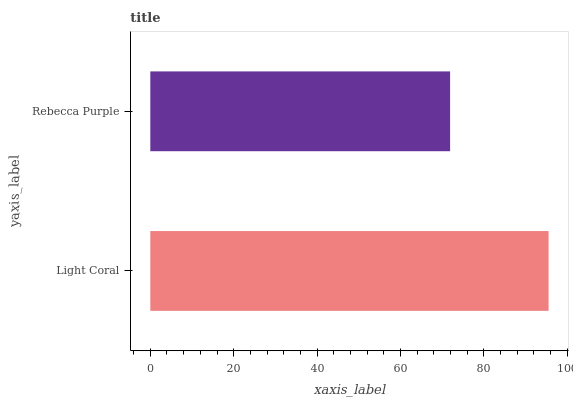Is Rebecca Purple the minimum?
Answer yes or no. Yes. Is Light Coral the maximum?
Answer yes or no. Yes. Is Rebecca Purple the maximum?
Answer yes or no. No. Is Light Coral greater than Rebecca Purple?
Answer yes or no. Yes. Is Rebecca Purple less than Light Coral?
Answer yes or no. Yes. Is Rebecca Purple greater than Light Coral?
Answer yes or no. No. Is Light Coral less than Rebecca Purple?
Answer yes or no. No. Is Light Coral the high median?
Answer yes or no. Yes. Is Rebecca Purple the low median?
Answer yes or no. Yes. Is Rebecca Purple the high median?
Answer yes or no. No. Is Light Coral the low median?
Answer yes or no. No. 